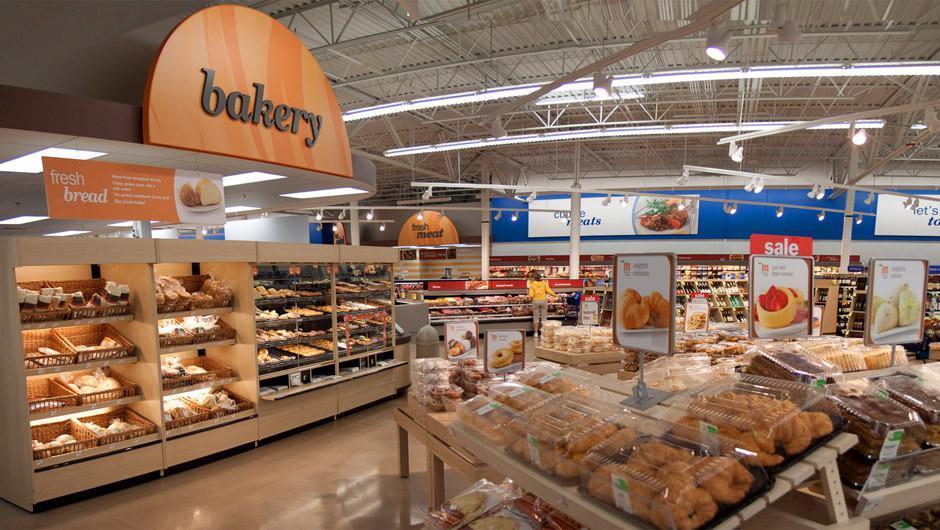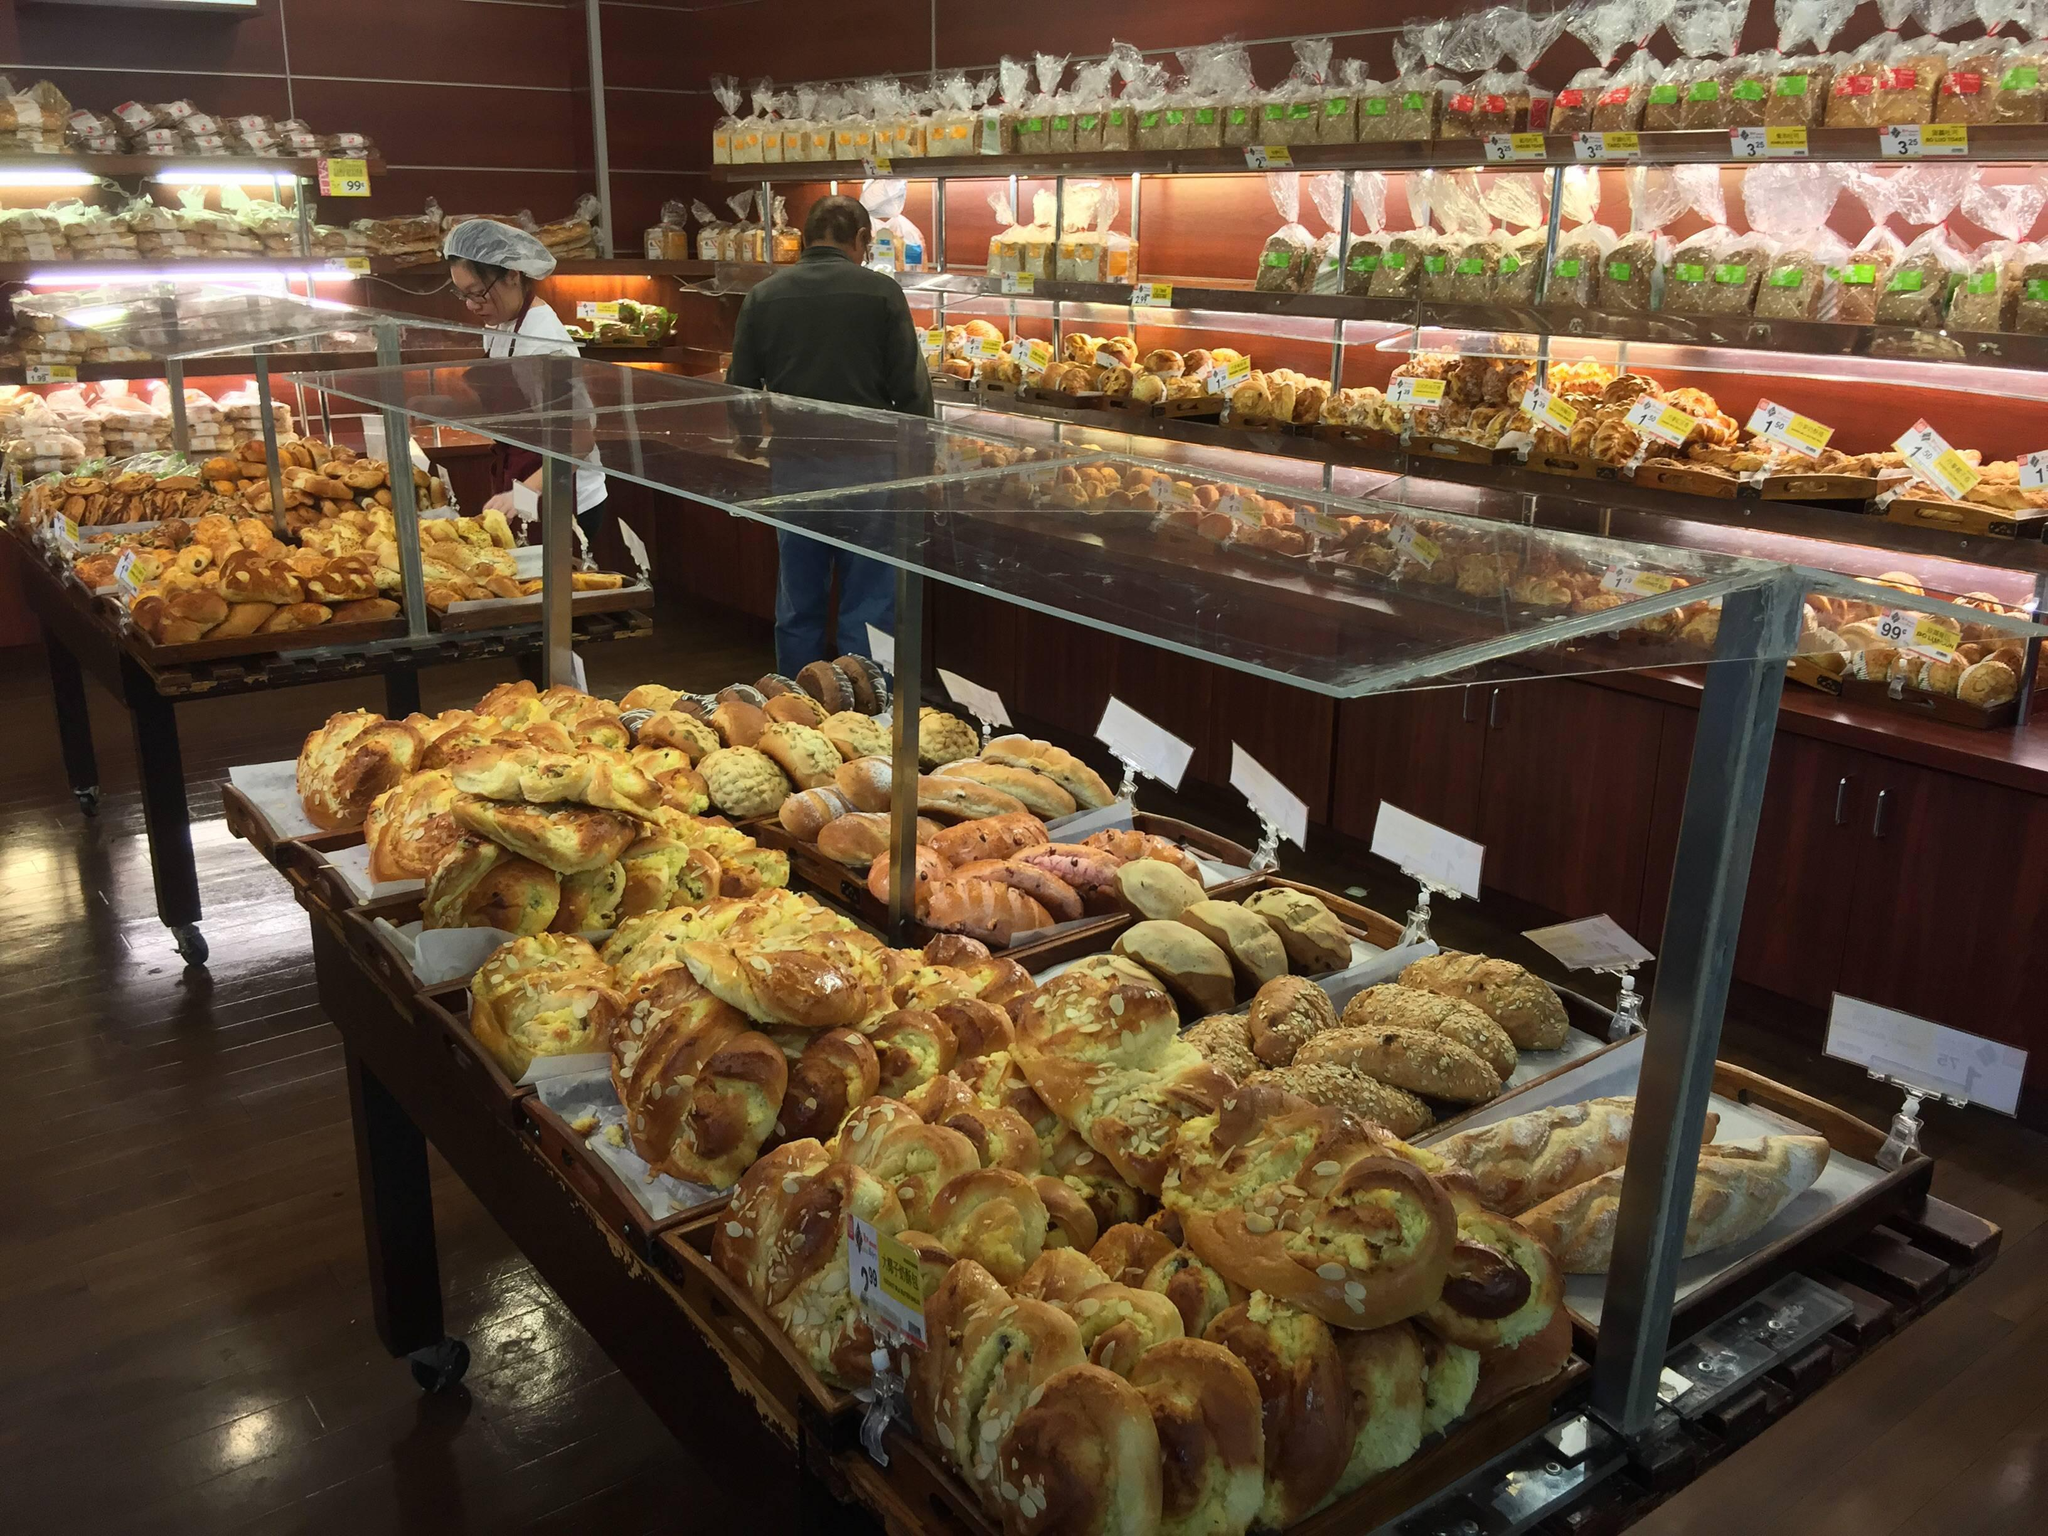The first image is the image on the left, the second image is the image on the right. Assess this claim about the two images: "Lefthand image features a bakery with a white rectangular sign with lettering only.". Correct or not? Answer yes or no. No. 